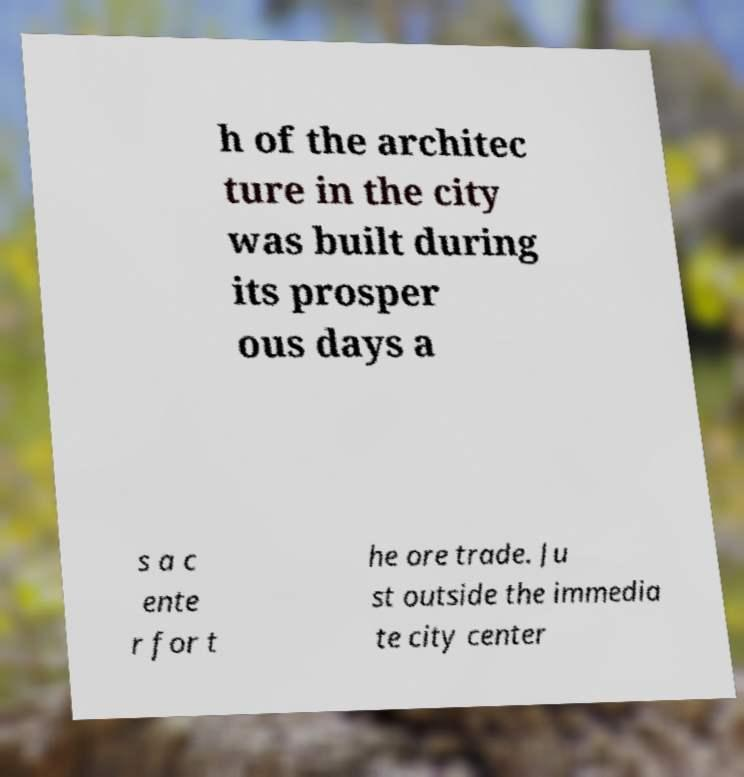Can you accurately transcribe the text from the provided image for me? h of the architec ture in the city was built during its prosper ous days a s a c ente r for t he ore trade. Ju st outside the immedia te city center 